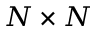Convert formula to latex. <formula><loc_0><loc_0><loc_500><loc_500>N \times N</formula> 